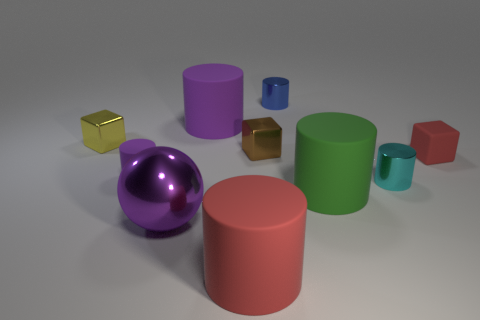Subtract all large green matte cylinders. How many cylinders are left? 5 Subtract all purple cylinders. How many cylinders are left? 4 Subtract all yellow cylinders. Subtract all green blocks. How many cylinders are left? 6 Subtract all cylinders. How many objects are left? 4 Add 3 balls. How many balls exist? 4 Subtract 0 blue cubes. How many objects are left? 10 Subtract all large red matte objects. Subtract all big green cylinders. How many objects are left? 8 Add 6 yellow metallic objects. How many yellow metallic objects are left? 7 